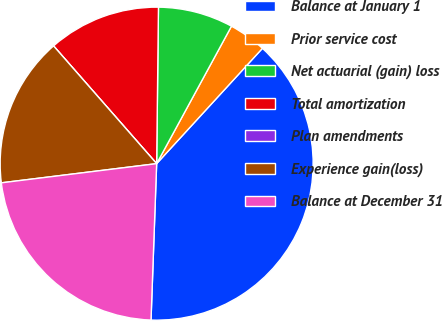Convert chart. <chart><loc_0><loc_0><loc_500><loc_500><pie_chart><fcel>Balance at January 1<fcel>Prior service cost<fcel>Net actuarial (gain) loss<fcel>Total amortization<fcel>Plan amendments<fcel>Experience gain(loss)<fcel>Balance at December 31<nl><fcel>38.76%<fcel>3.88%<fcel>7.75%<fcel>11.63%<fcel>0.0%<fcel>15.51%<fcel>22.47%<nl></chart> 